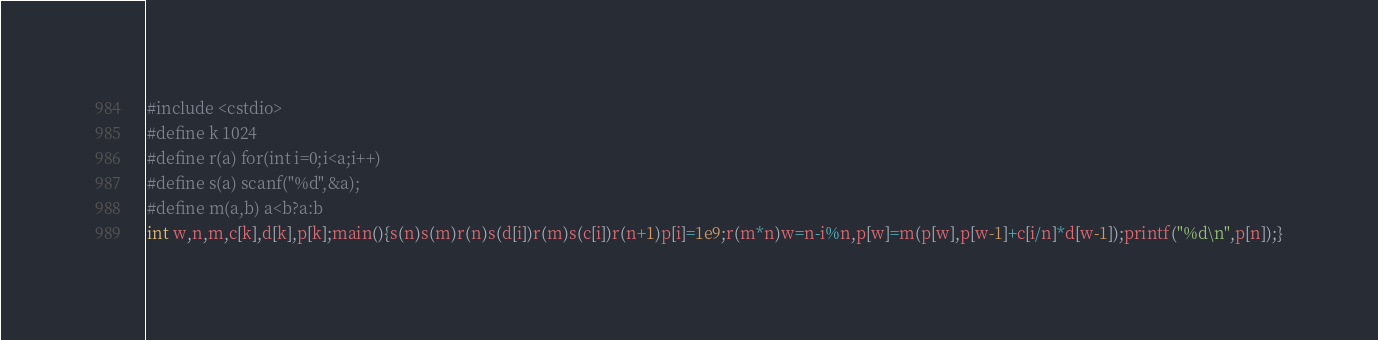<code> <loc_0><loc_0><loc_500><loc_500><_C++_>#include <cstdio>
#define k 1024
#define r(a) for(int i=0;i<a;i++)
#define s(a) scanf("%d",&a);
#define m(a,b) a<b?a:b
int w,n,m,c[k],d[k],p[k];main(){s(n)s(m)r(n)s(d[i])r(m)s(c[i])r(n+1)p[i]=1e9;r(m*n)w=n-i%n,p[w]=m(p[w],p[w-1]+c[i/n]*d[w-1]);printf("%d\n",p[n]);}</code> 